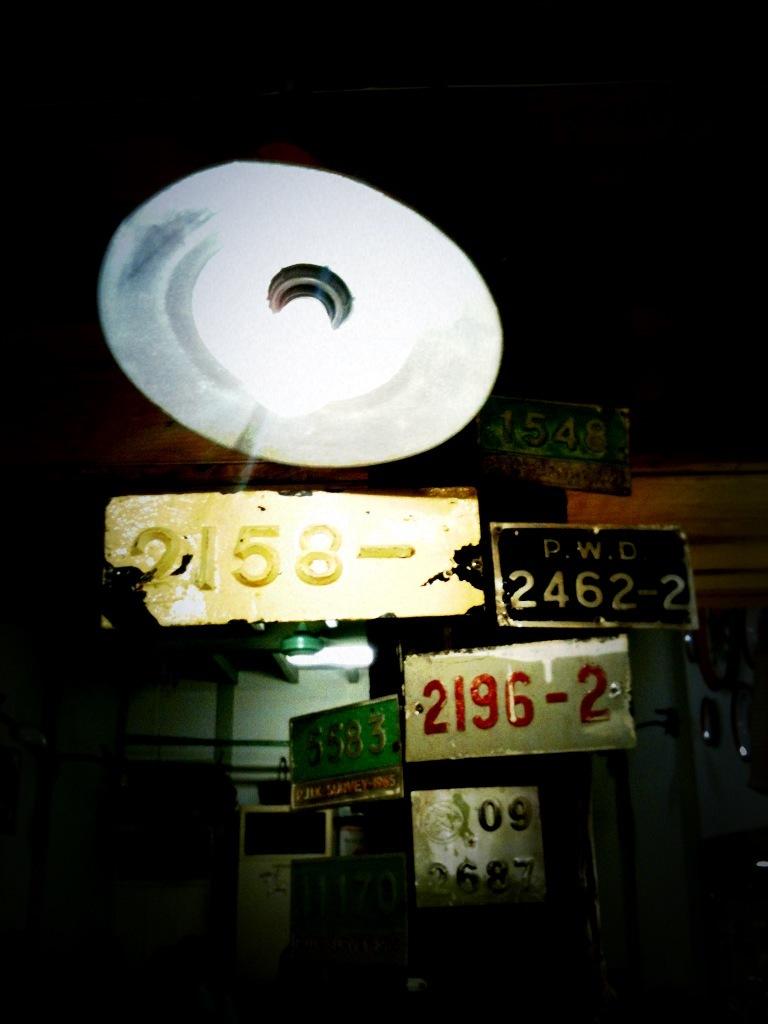What is on the black sign?
Keep it short and to the point. 2462-2. 